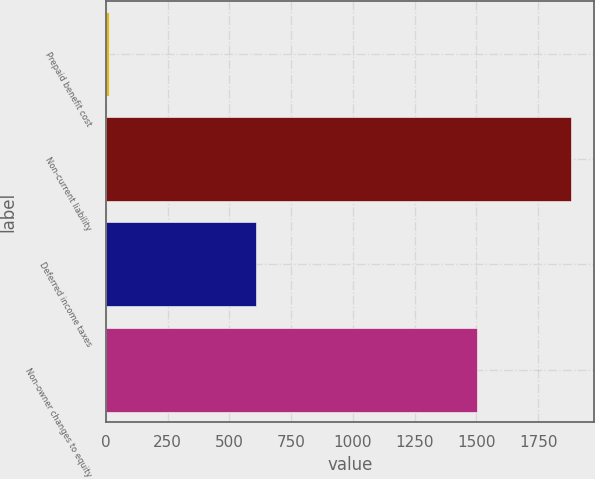Convert chart. <chart><loc_0><loc_0><loc_500><loc_500><bar_chart><fcel>Prepaid benefit cost<fcel>Non-current liability<fcel>Deferred income taxes<fcel>Non-owner changes to equity<nl><fcel>13<fcel>1882<fcel>608<fcel>1503<nl></chart> 